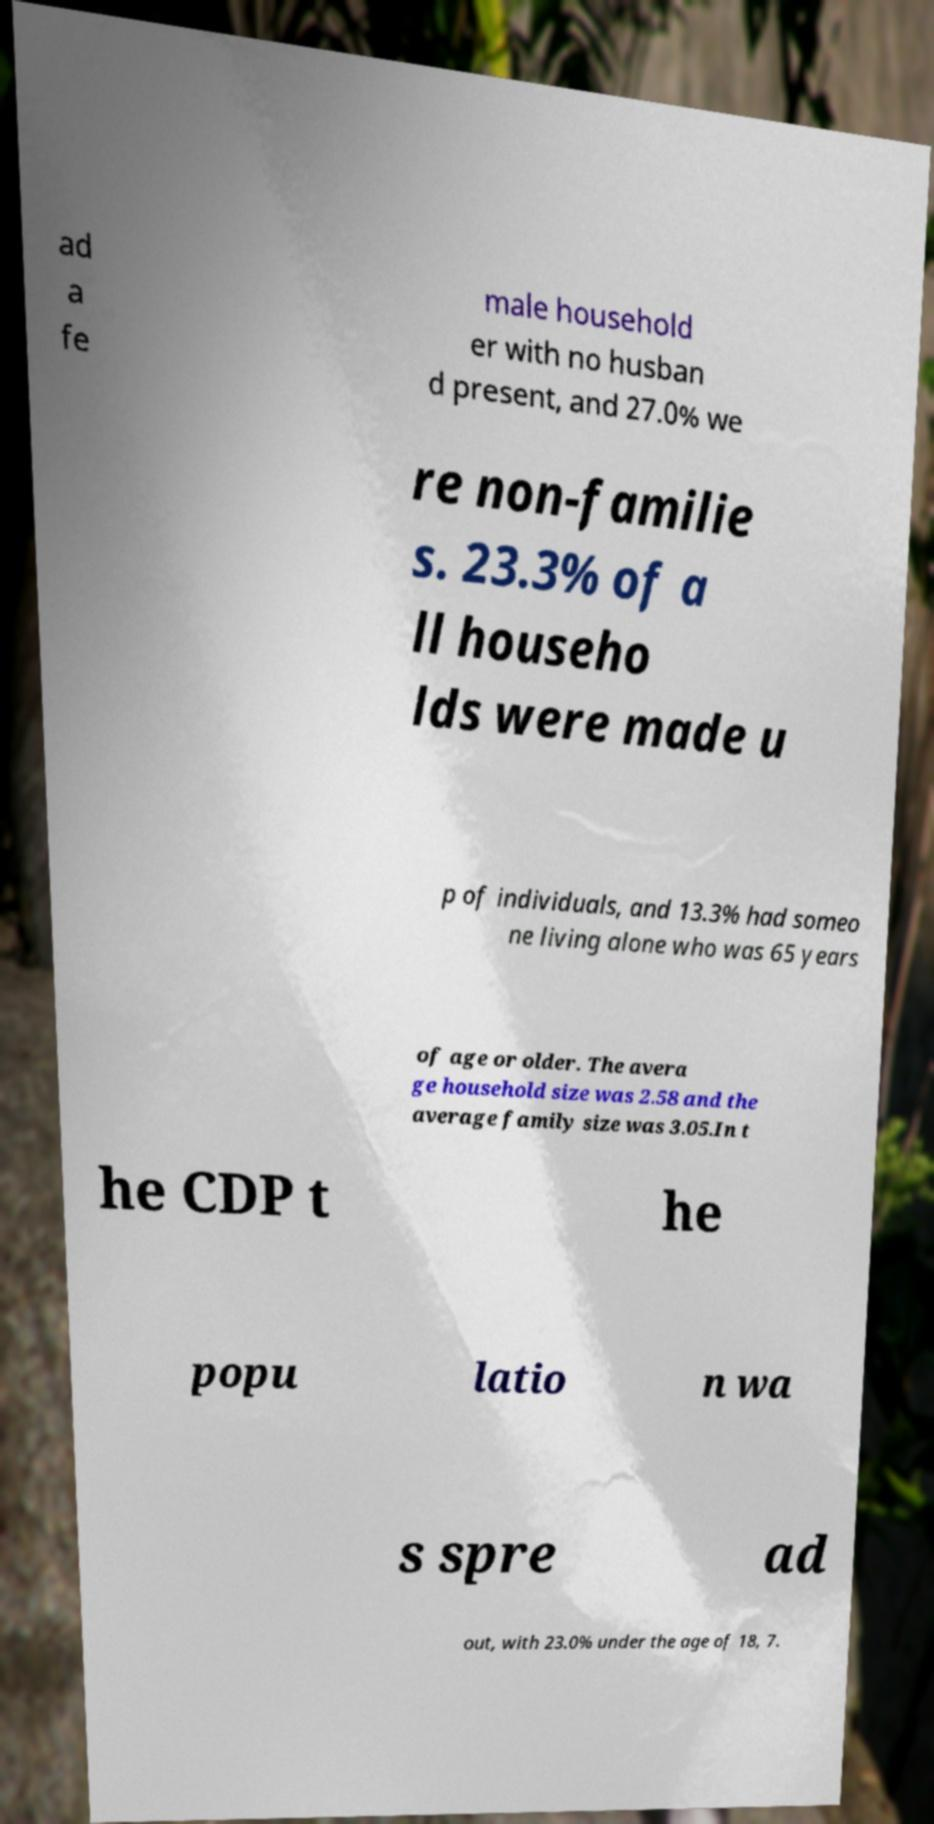Could you extract and type out the text from this image? ad a fe male household er with no husban d present, and 27.0% we re non-familie s. 23.3% of a ll househo lds were made u p of individuals, and 13.3% had someo ne living alone who was 65 years of age or older. The avera ge household size was 2.58 and the average family size was 3.05.In t he CDP t he popu latio n wa s spre ad out, with 23.0% under the age of 18, 7. 